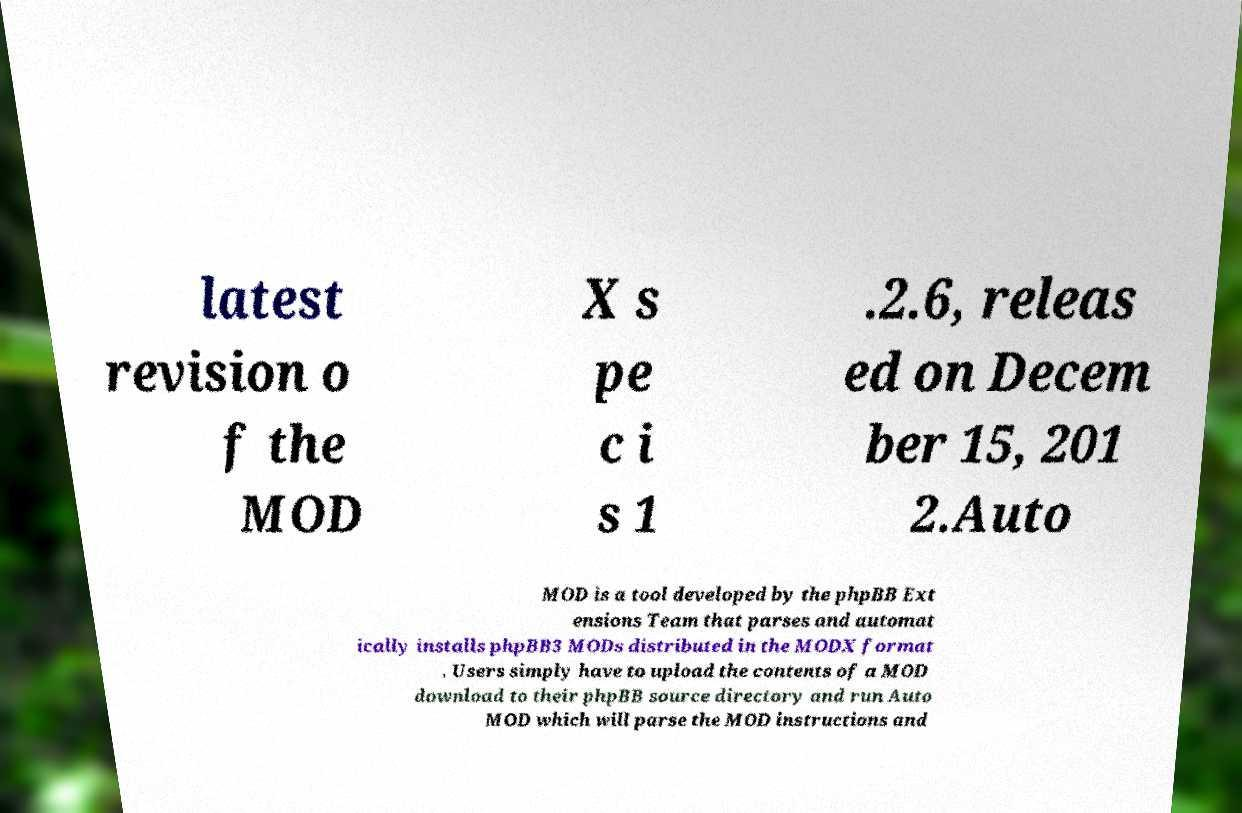Can you read and provide the text displayed in the image?This photo seems to have some interesting text. Can you extract and type it out for me? latest revision o f the MOD X s pe c i s 1 .2.6, releas ed on Decem ber 15, 201 2.Auto MOD is a tool developed by the phpBB Ext ensions Team that parses and automat ically installs phpBB3 MODs distributed in the MODX format . Users simply have to upload the contents of a MOD download to their phpBB source directory and run Auto MOD which will parse the MOD instructions and 